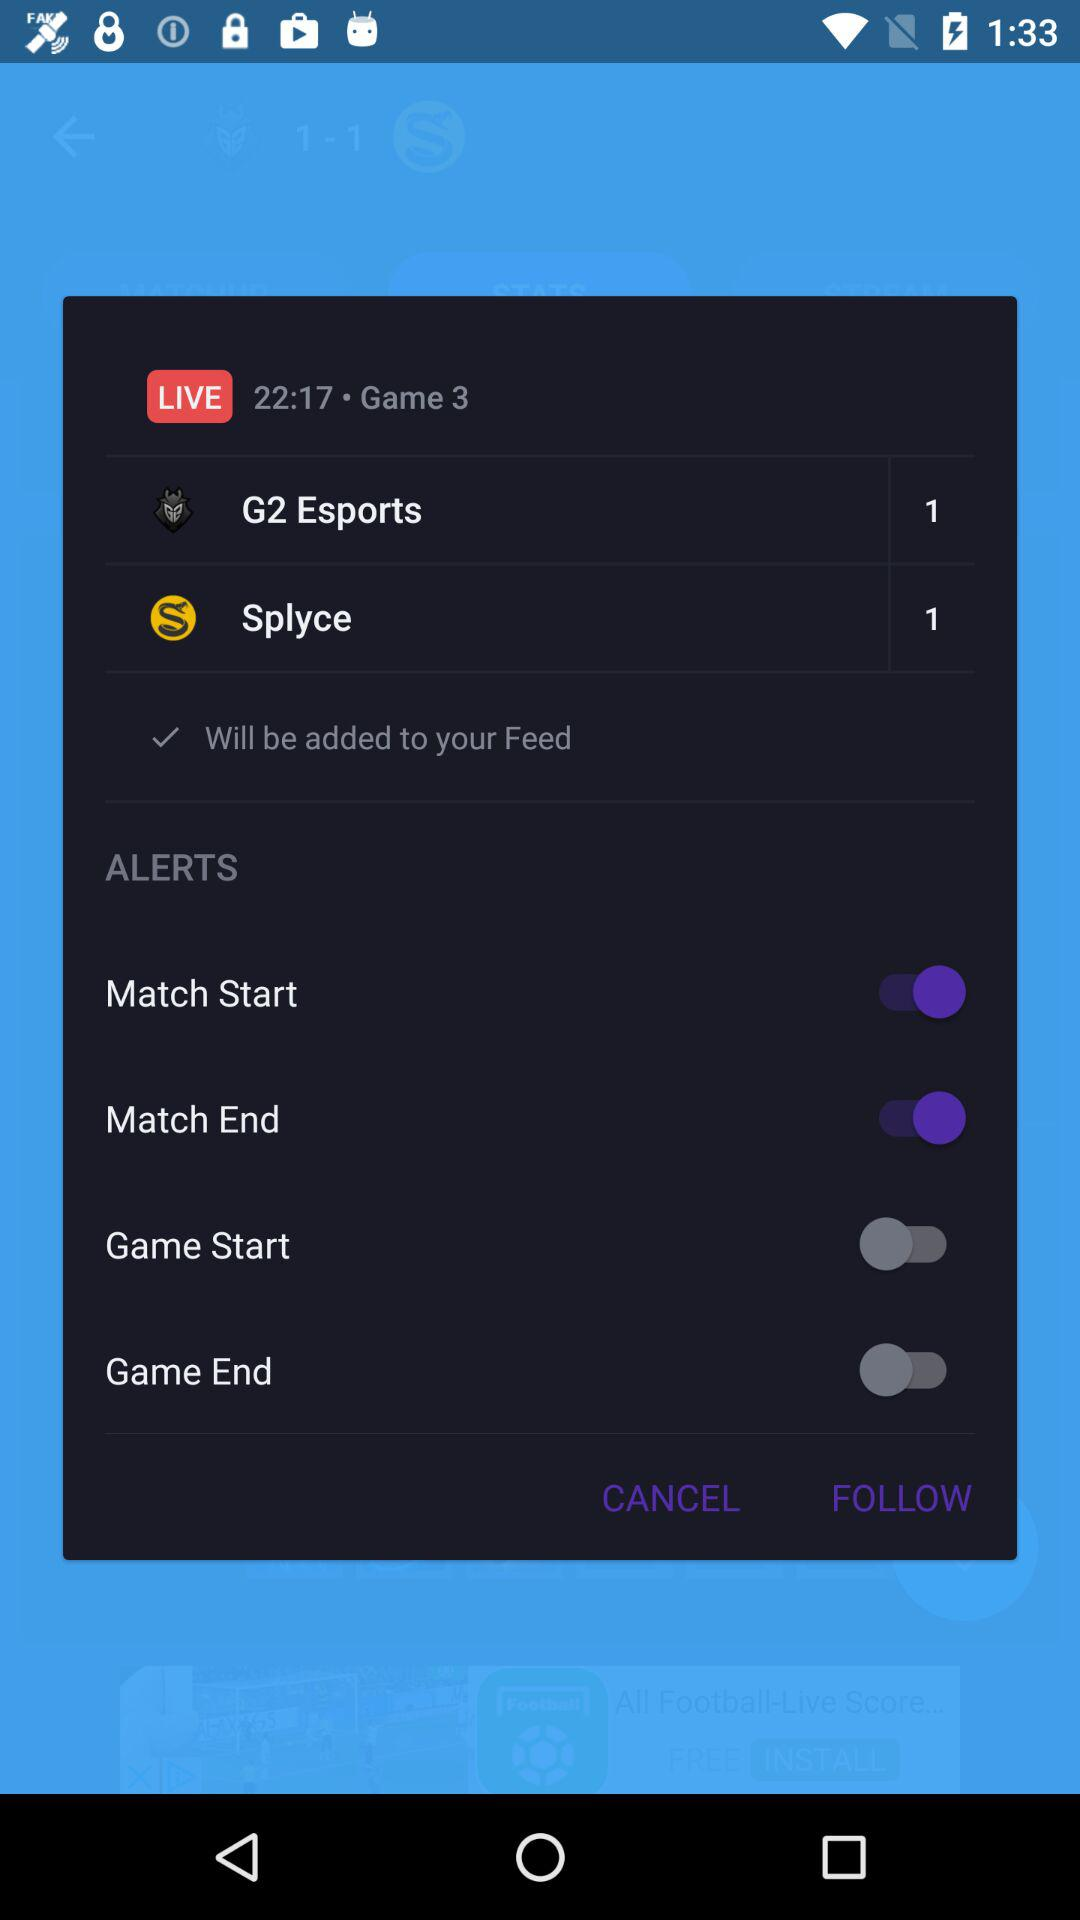What is the status of the "Match End"? The status is on. 